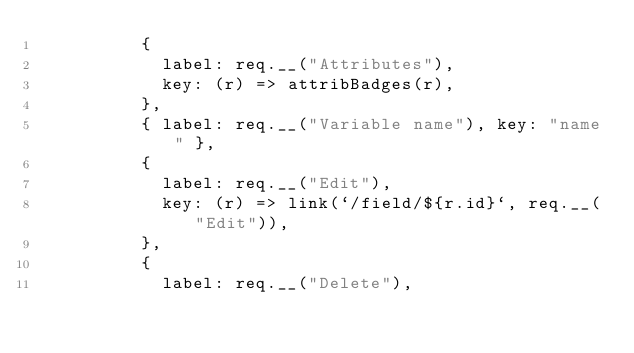<code> <loc_0><loc_0><loc_500><loc_500><_JavaScript_>          {
            label: req.__("Attributes"),
            key: (r) => attribBadges(r),
          },
          { label: req.__("Variable name"), key: "name" },
          {
            label: req.__("Edit"),
            key: (r) => link(`/field/${r.id}`, req.__("Edit")),
          },
          {
            label: req.__("Delete"),</code> 